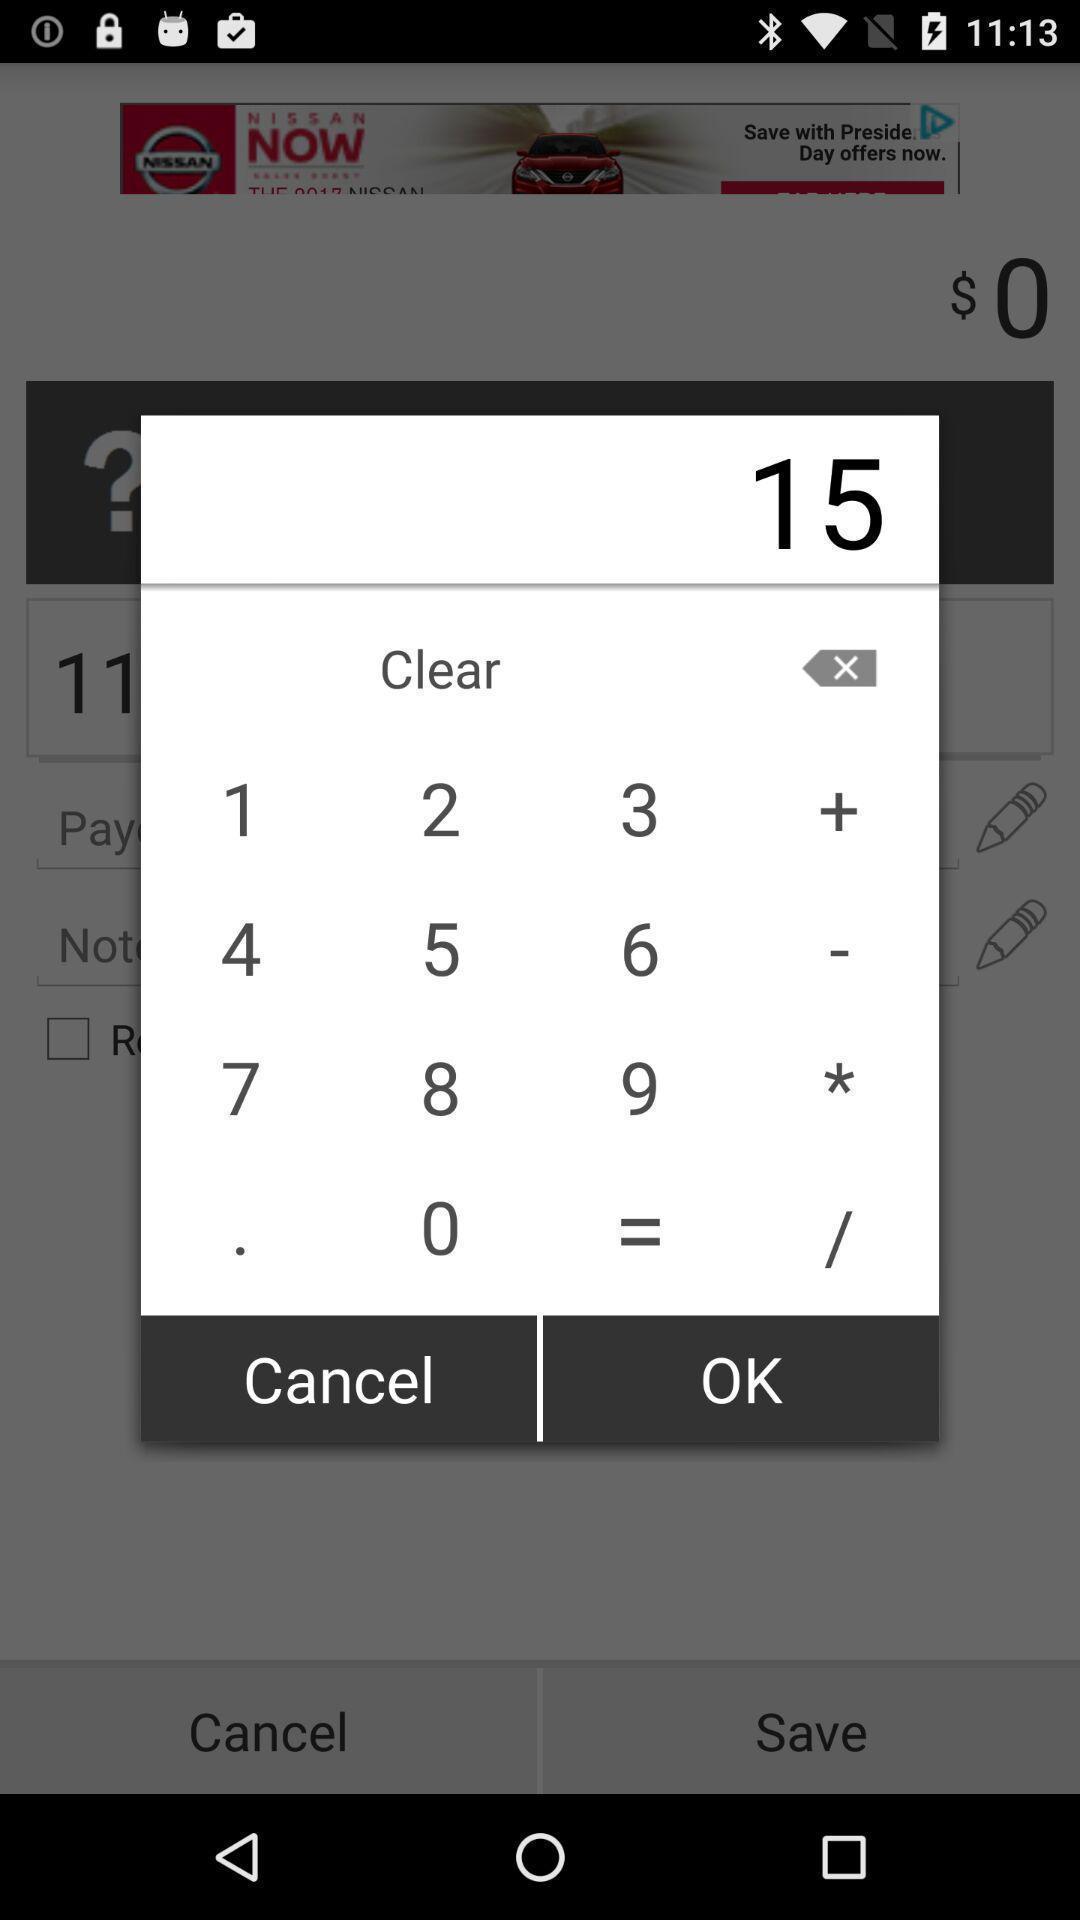Explain what's happening in this screen capture. Pop up notification of a calculator app. 